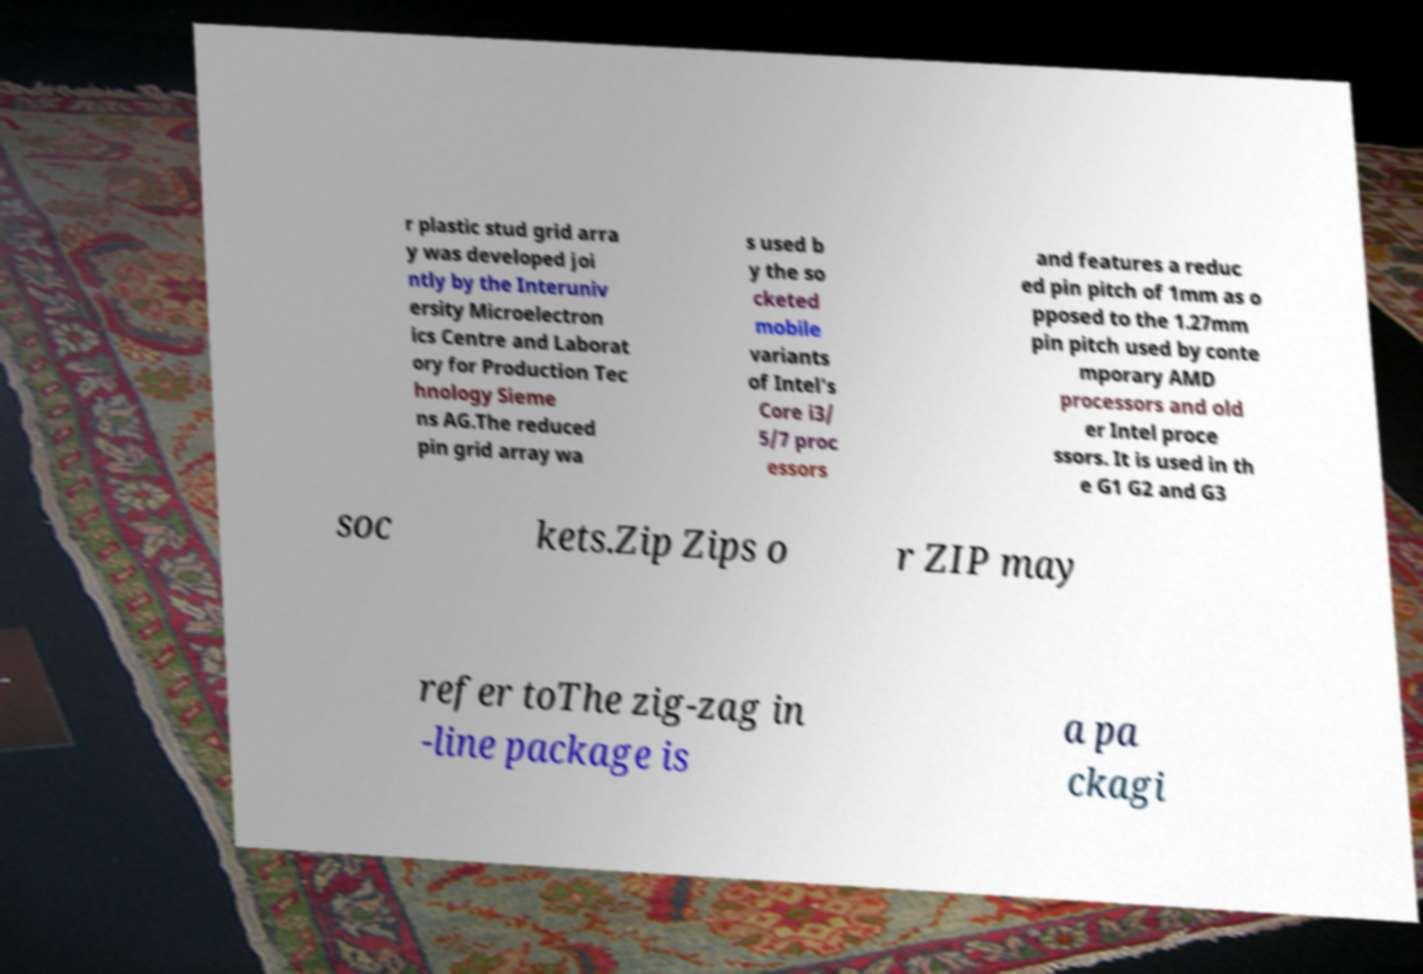Can you read and provide the text displayed in the image?This photo seems to have some interesting text. Can you extract and type it out for me? r plastic stud grid arra y was developed joi ntly by the Interuniv ersity Microelectron ics Centre and Laborat ory for Production Tec hnology Sieme ns AG.The reduced pin grid array wa s used b y the so cketed mobile variants of Intel's Core i3/ 5/7 proc essors and features a reduc ed pin pitch of 1mm as o pposed to the 1.27mm pin pitch used by conte mporary AMD processors and old er Intel proce ssors. It is used in th e G1 G2 and G3 soc kets.Zip Zips o r ZIP may refer toThe zig-zag in -line package is a pa ckagi 